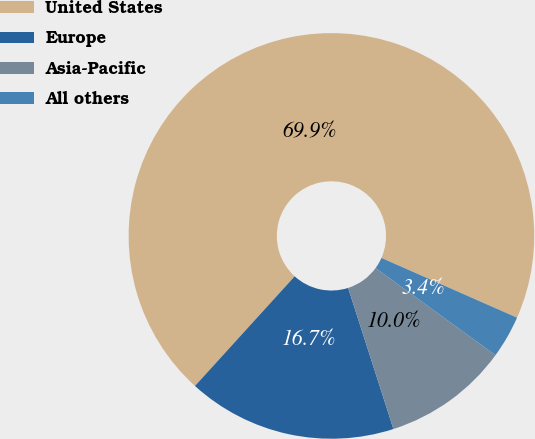<chart> <loc_0><loc_0><loc_500><loc_500><pie_chart><fcel>United States<fcel>Europe<fcel>Asia-Pacific<fcel>All others<nl><fcel>69.86%<fcel>16.69%<fcel>10.05%<fcel>3.4%<nl></chart> 